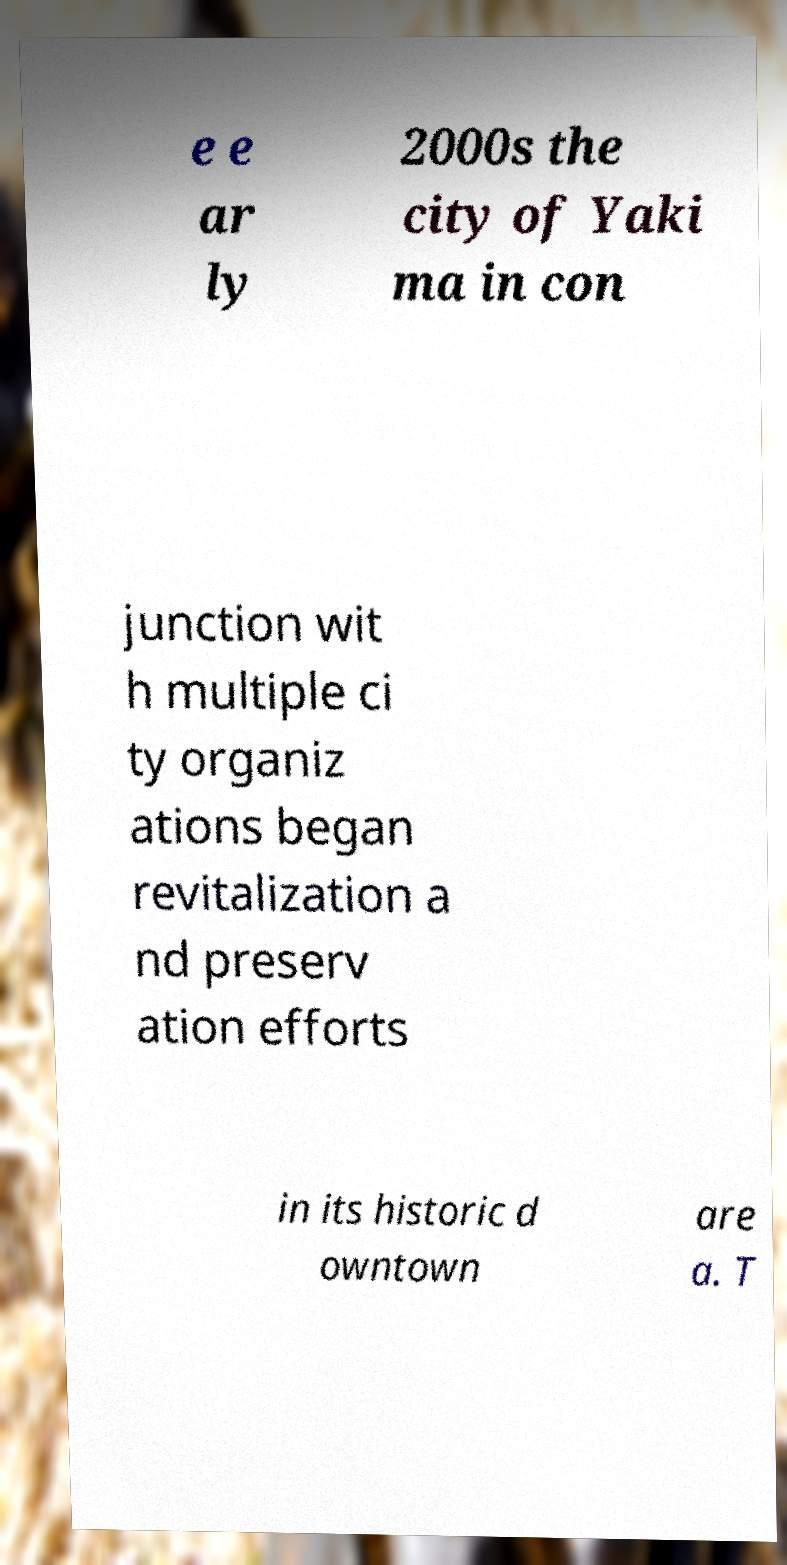Can you read and provide the text displayed in the image?This photo seems to have some interesting text. Can you extract and type it out for me? e e ar ly 2000s the city of Yaki ma in con junction wit h multiple ci ty organiz ations began revitalization a nd preserv ation efforts in its historic d owntown are a. T 